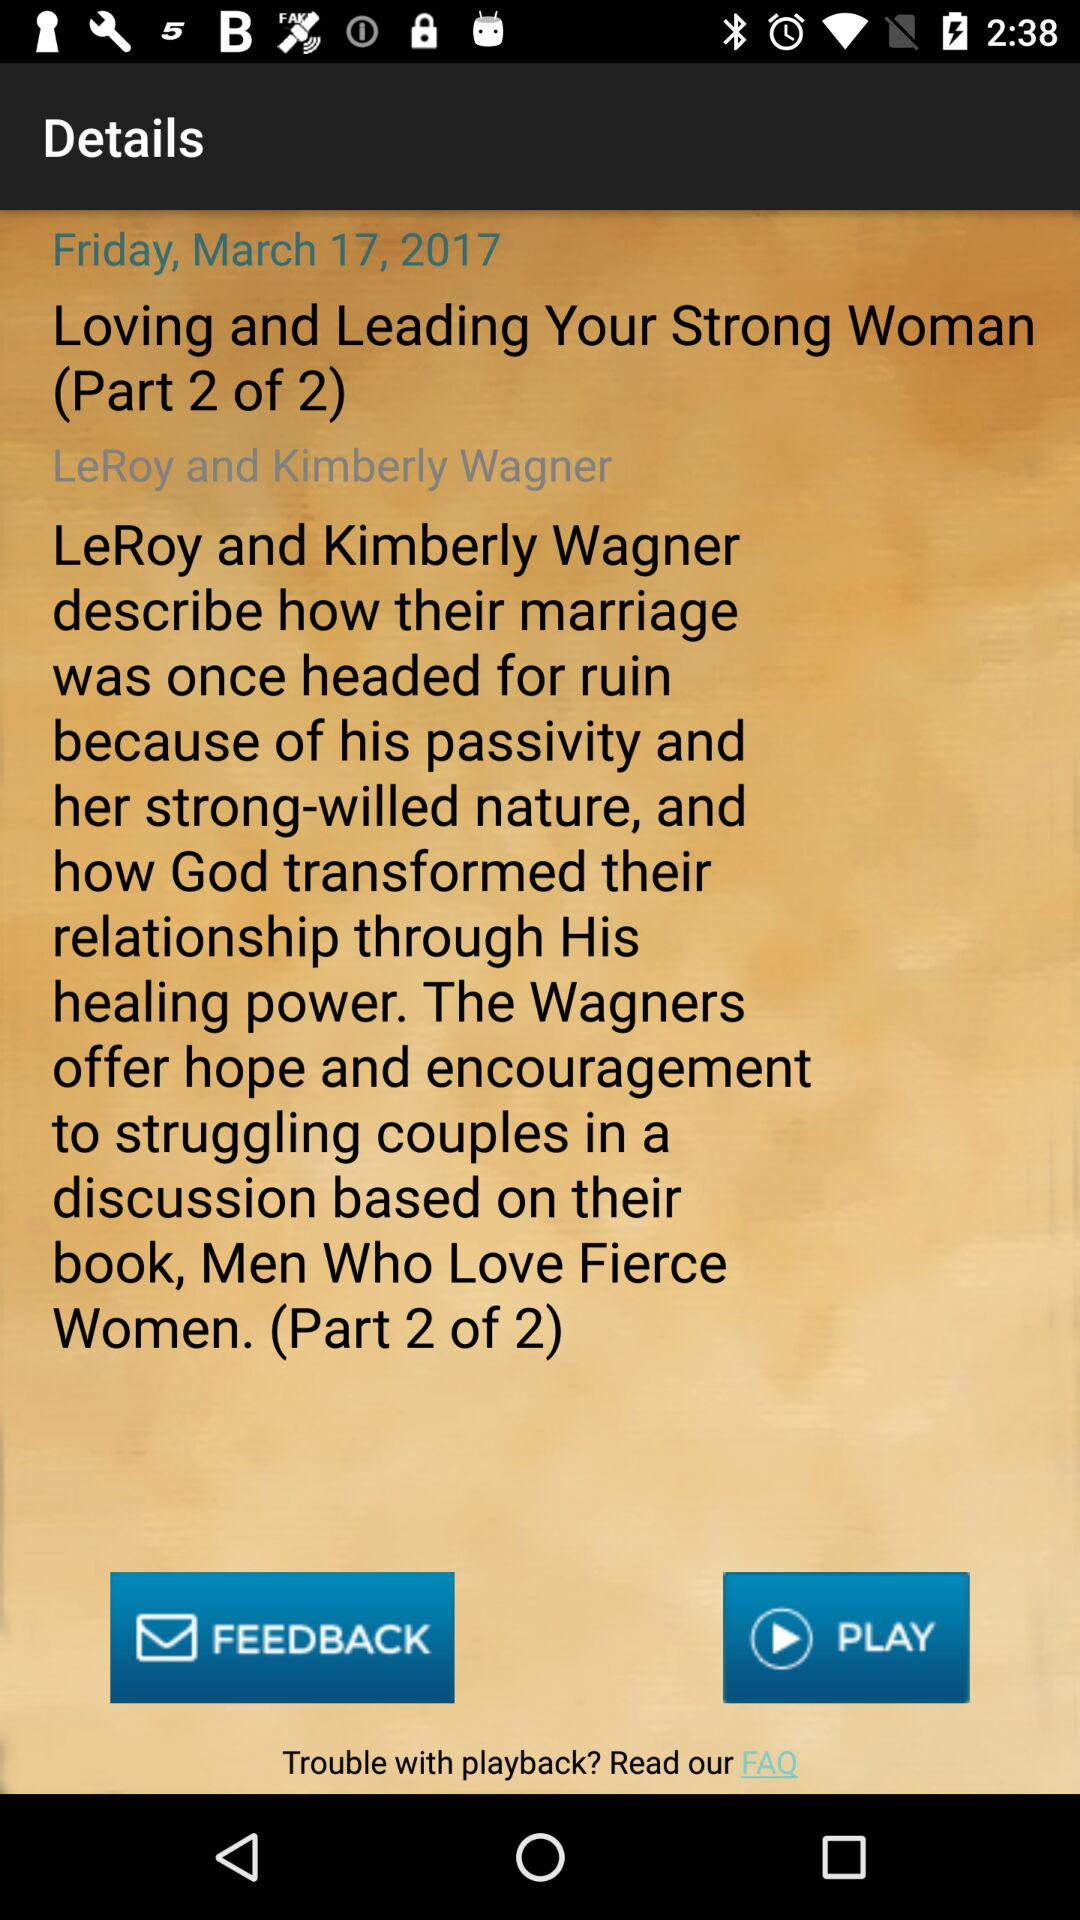What is the date? The date is Friday, March 17, 2017. 